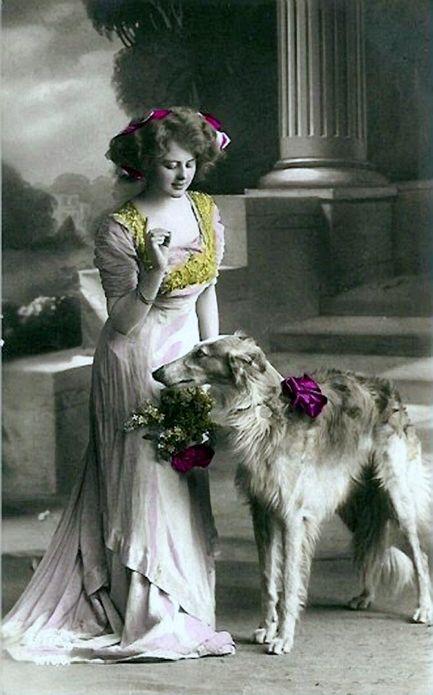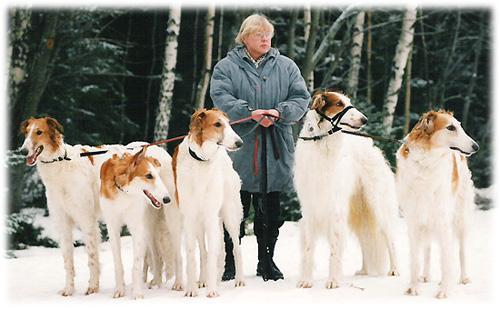The first image is the image on the left, the second image is the image on the right. Evaluate the accuracy of this statement regarding the images: "The right image contains exactly two dogs.". Is it true? Answer yes or no. No. The first image is the image on the left, the second image is the image on the right. Evaluate the accuracy of this statement regarding the images: "A woman is holding a single dog on a leash.". Is it true? Answer yes or no. No. 